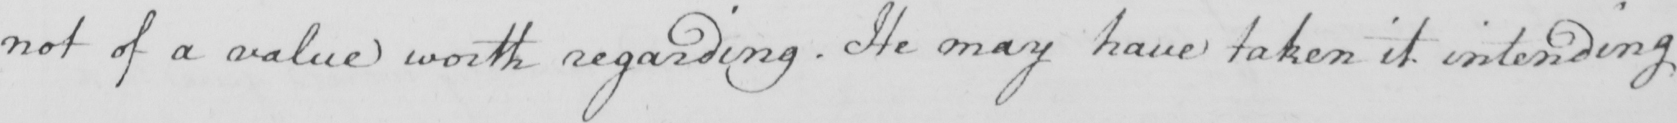Please transcribe the handwritten text in this image. not of a value worth regarding . He may have taken it intending 